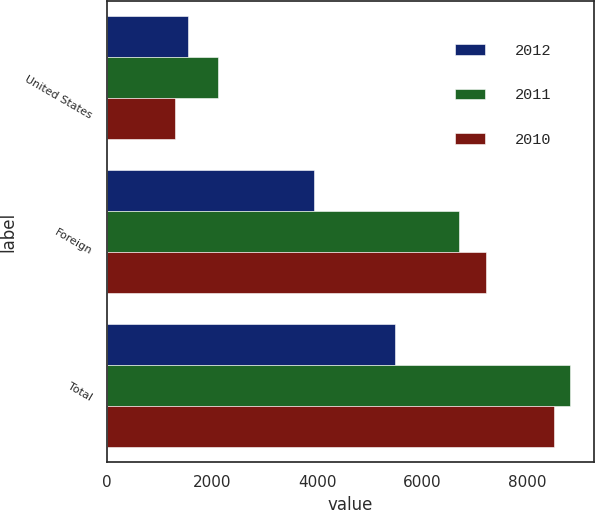Convert chart to OTSL. <chart><loc_0><loc_0><loc_500><loc_500><stacked_bar_chart><ecel><fcel>United States<fcel>Foreign<fcel>Total<nl><fcel>2012<fcel>1539<fcel>3948<fcel>5487<nl><fcel>2011<fcel>2112<fcel>6706<fcel>8818<nl><fcel>2010<fcel>1307<fcel>7205<fcel>8512<nl></chart> 